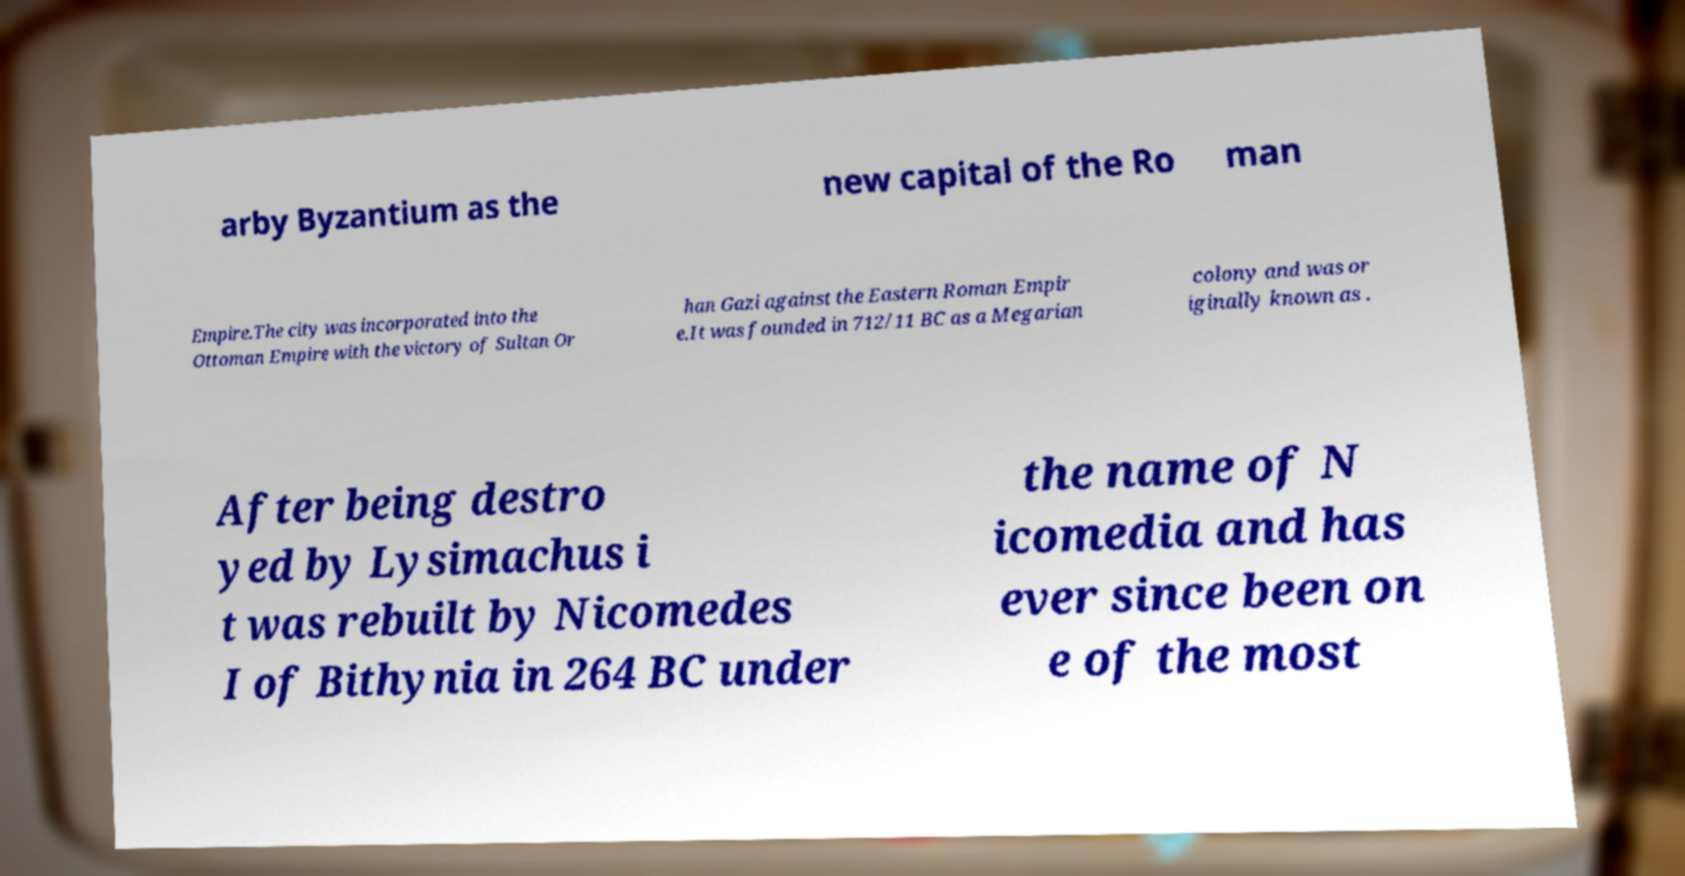Could you assist in decoding the text presented in this image and type it out clearly? arby Byzantium as the new capital of the Ro man Empire.The city was incorporated into the Ottoman Empire with the victory of Sultan Or han Gazi against the Eastern Roman Empir e.It was founded in 712/11 BC as a Megarian colony and was or iginally known as . After being destro yed by Lysimachus i t was rebuilt by Nicomedes I of Bithynia in 264 BC under the name of N icomedia and has ever since been on e of the most 